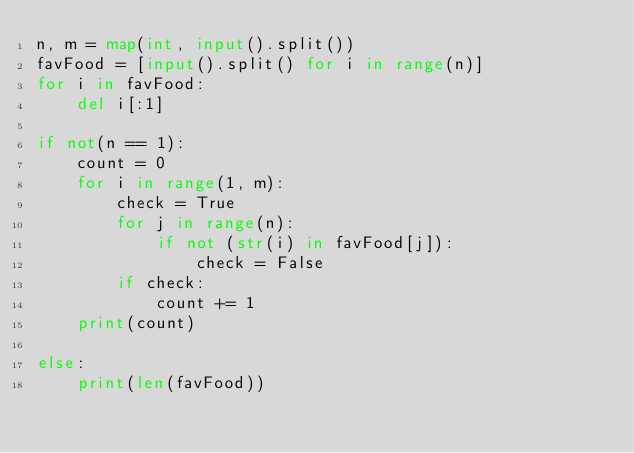Convert code to text. <code><loc_0><loc_0><loc_500><loc_500><_Python_>n, m = map(int, input().split())
favFood = [input().split() for i in range(n)]
for i in favFood:
    del i[:1]

if not(n == 1):
    count = 0
    for i in range(1, m):
        check = True
        for j in range(n):
            if not (str(i) in favFood[j]):
                check = False
        if check:
            count += 1
    print(count)

else:
    print(len(favFood))

</code> 